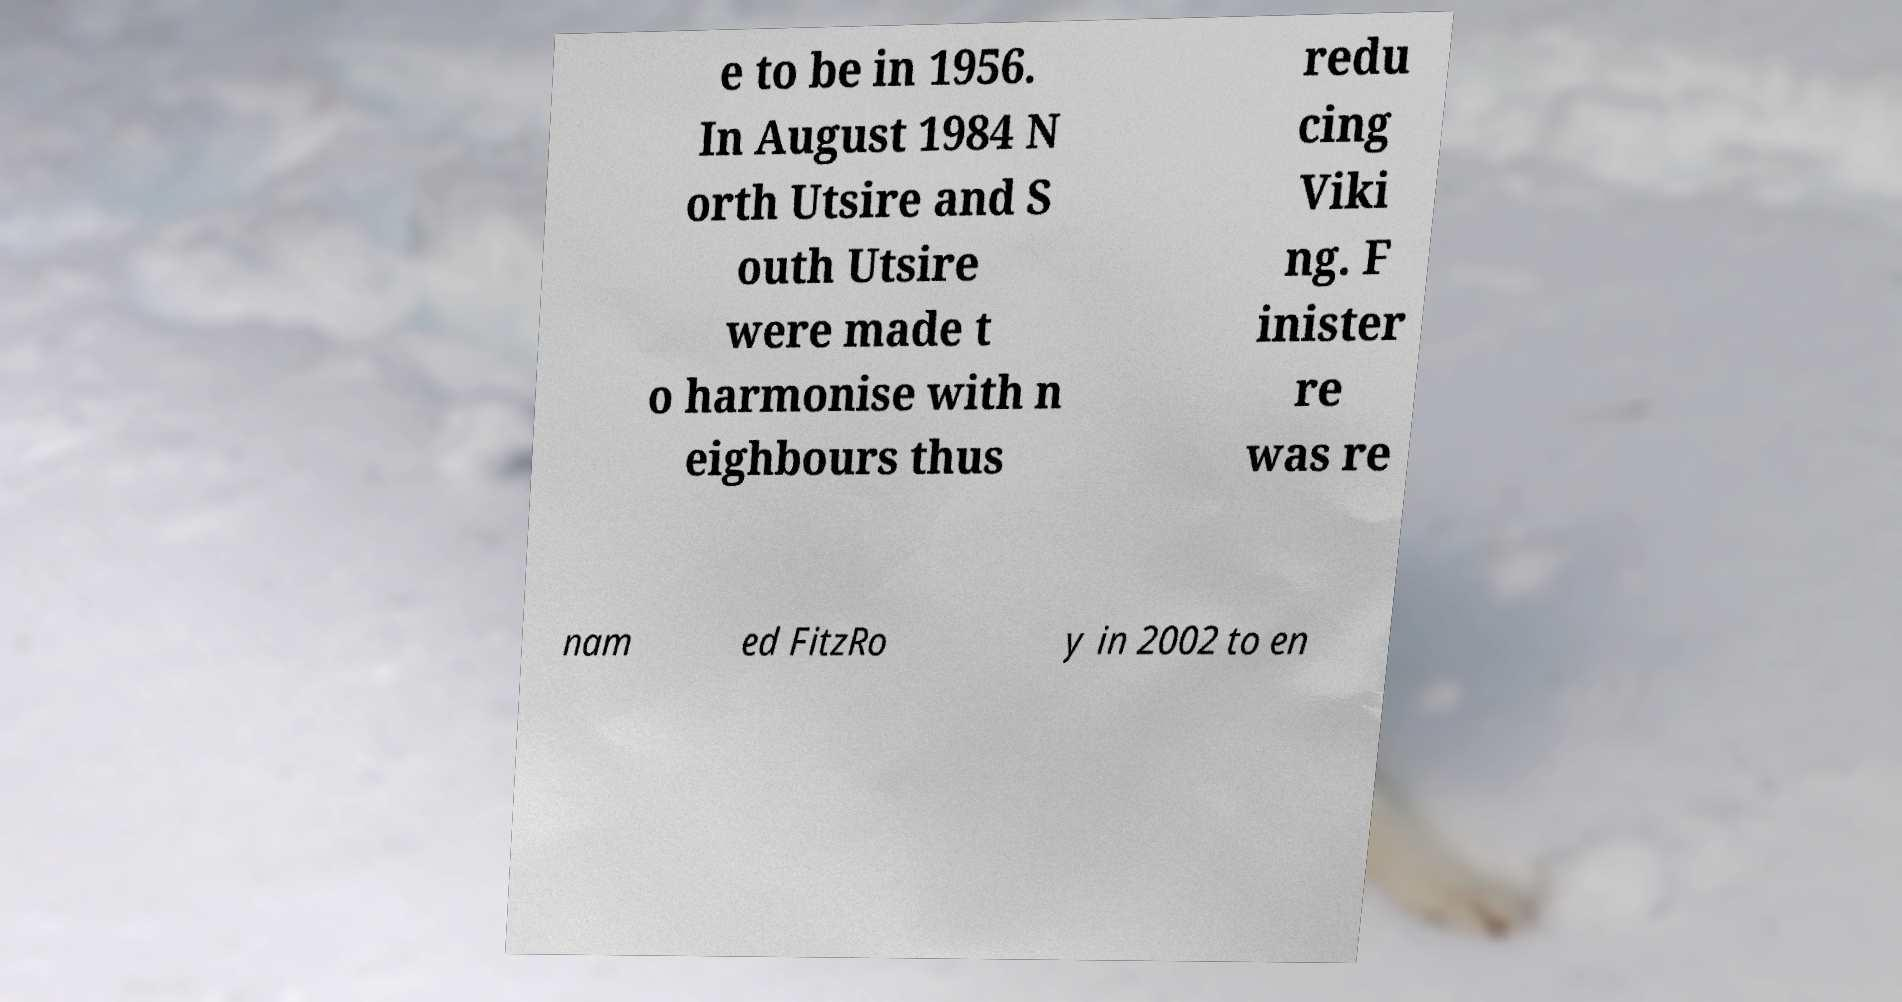Could you assist in decoding the text presented in this image and type it out clearly? e to be in 1956. In August 1984 N orth Utsire and S outh Utsire were made t o harmonise with n eighbours thus redu cing Viki ng. F inister re was re nam ed FitzRo y in 2002 to en 